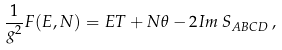<formula> <loc_0><loc_0><loc_500><loc_500>\frac { 1 } { g ^ { 2 } } F ( E , N ) = E T + N \theta - 2 I m \, S _ { A B C D } \, ,</formula> 